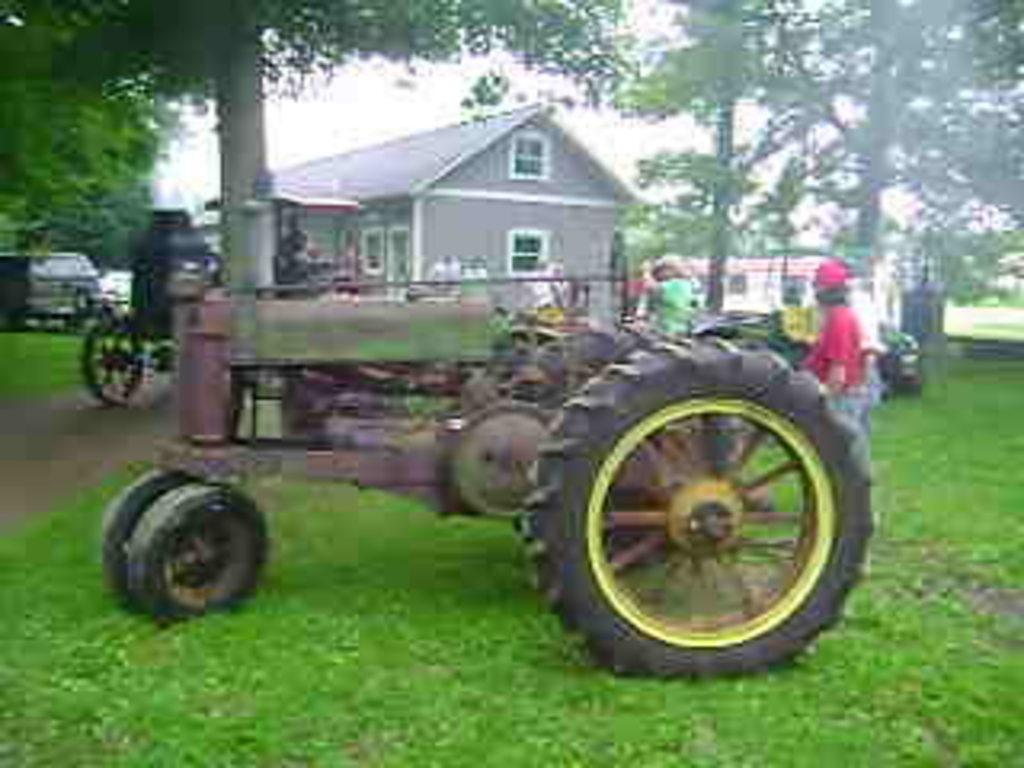What type of structure is present in the image? There is a building in the picture. What vehicle can be seen in the image? There is a truck in the picture. What type of vegetation is present in the image? There are trees in the picture. What is the condition of the sky in the image? The sky is clear in the image. What type of smell can be detected from the truck in the image? There is no information about the smell of the truck in the image, so it cannot be determined. What is the cannon used for in the image? There is no cannon present in the image. 